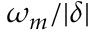Convert formula to latex. <formula><loc_0><loc_0><loc_500><loc_500>\omega _ { m } / | \delta |</formula> 